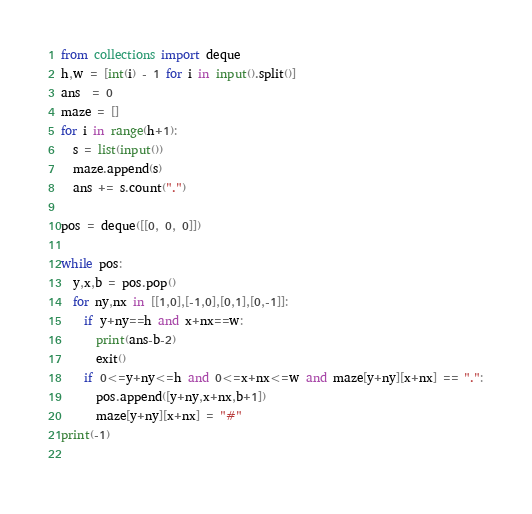<code> <loc_0><loc_0><loc_500><loc_500><_Python_>from collections import deque
h,w = [int(i) - 1 for i in input().split()]
ans  = 0
maze = []
for i in range(h+1):
  s = list(input())
  maze.append(s)
  ans += s.count(".")

pos = deque([[0, 0, 0]])

while pos:
  y,x,b = pos.pop()
  for ny,nx in [[1,0],[-1,0],[0,1],[0,-1]]:
    if y+ny==h and x+nx==w:
      print(ans-b-2)
      exit()
    if 0<=y+ny<=h and 0<=x+nx<=w and maze[y+ny][x+nx] == ".":
      pos.append([y+ny,x+nx,b+1])
      maze[y+ny][x+nx] = "#"
print(-1)
    </code> 